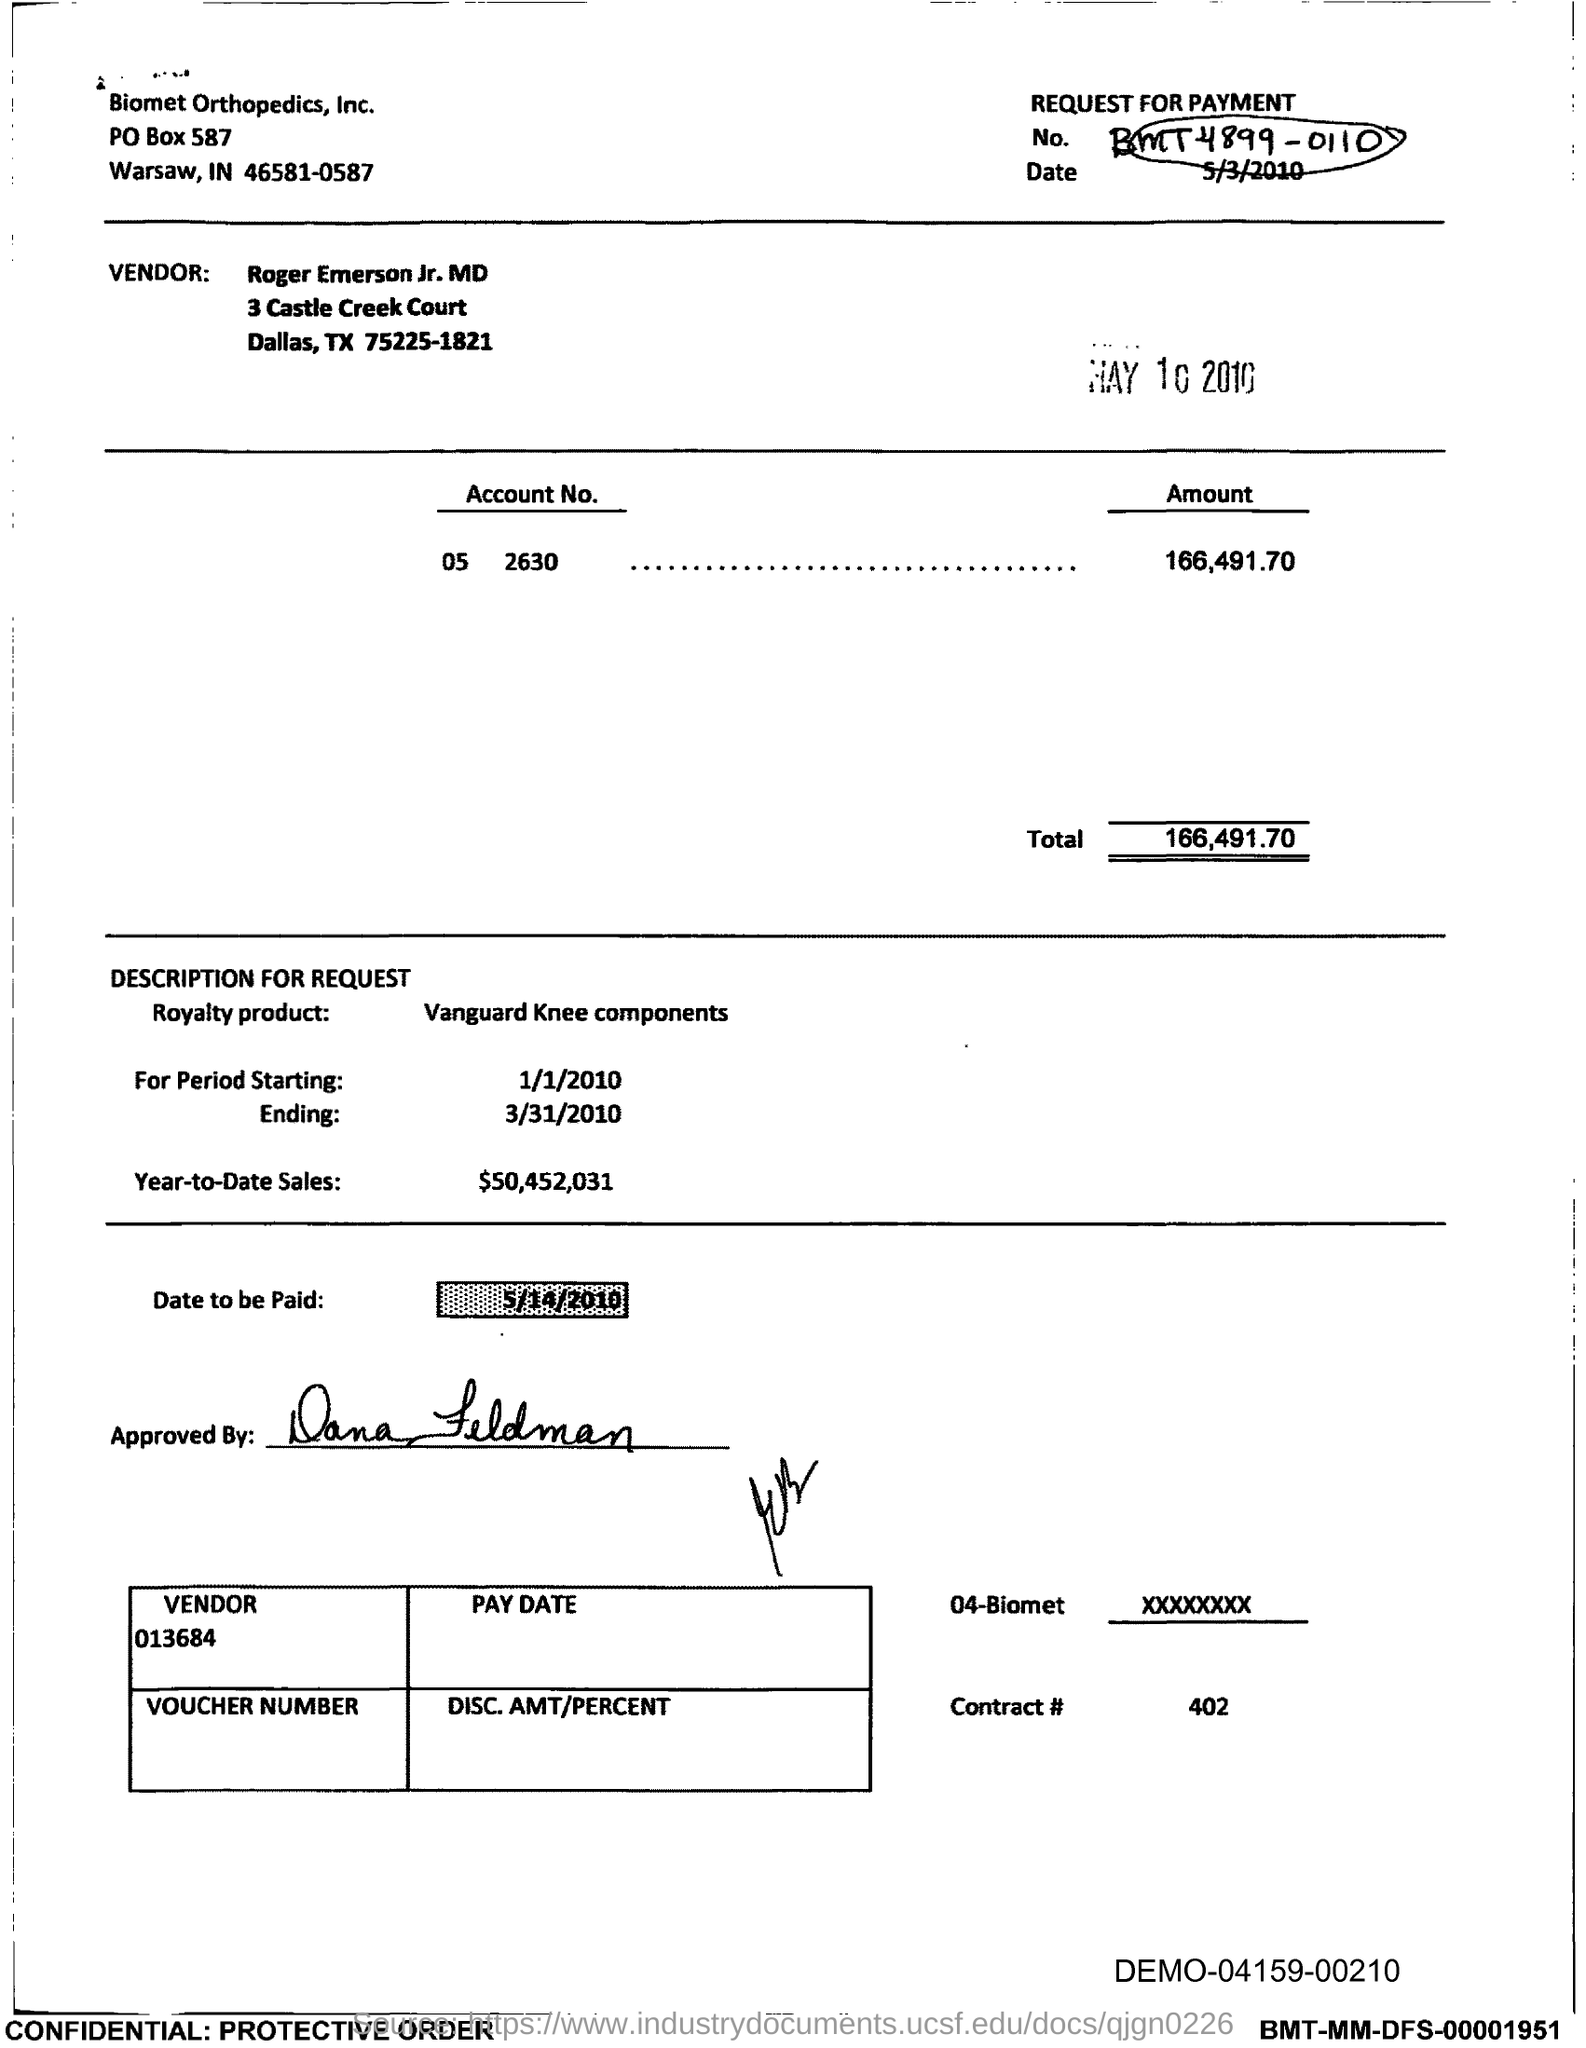What is the amount mentioned in this voucher?
Provide a succinct answer. 166,491.70. 